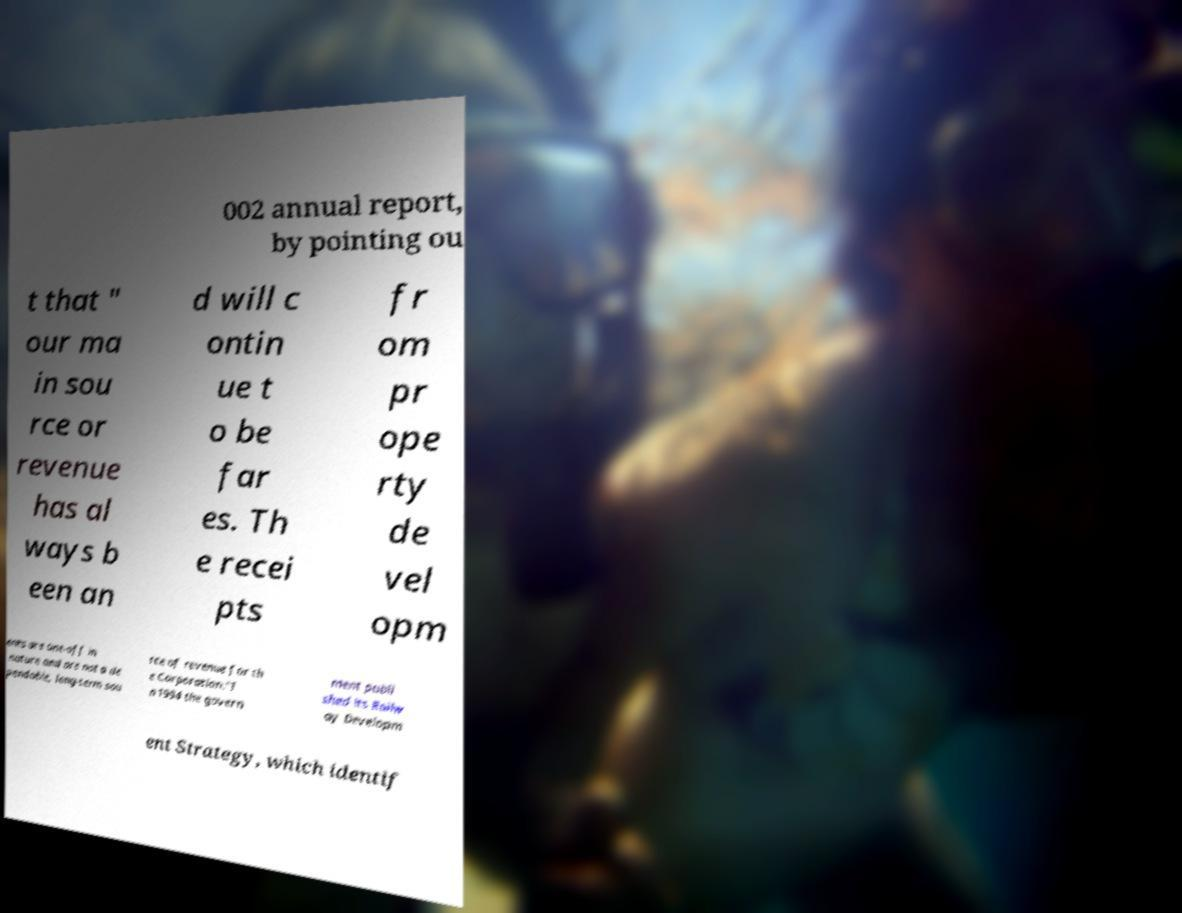I need the written content from this picture converted into text. Can you do that? 002 annual report, by pointing ou t that " our ma in sou rce or revenue has al ways b een an d will c ontin ue t o be far es. Th e recei pts fr om pr ope rty de vel opm ents are one-off in nature and are not a de pendable, long-term sou rce of revenue for th e Corporation."I n 1994 the govern ment publi shed its Railw ay Developm ent Strategy, which identif 